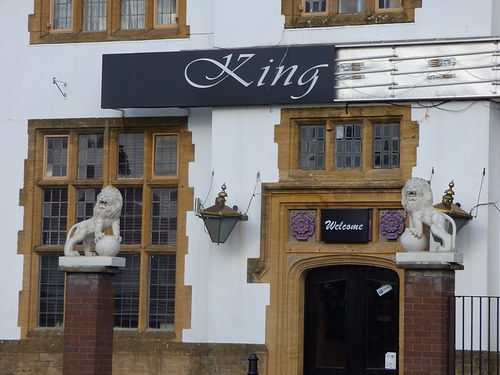<image>
Is the lion statue above the brick pillar? Yes. The lion statue is positioned above the brick pillar in the vertical space, higher up in the scene. 